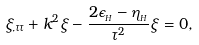<formula> <loc_0><loc_0><loc_500><loc_500>\xi _ { , \tau \tau } + k ^ { 2 } \xi - \frac { 2 \epsilon _ { _ { H } } - \eta _ { _ { H } } } { \tau ^ { 2 } } \xi = 0 ,</formula> 